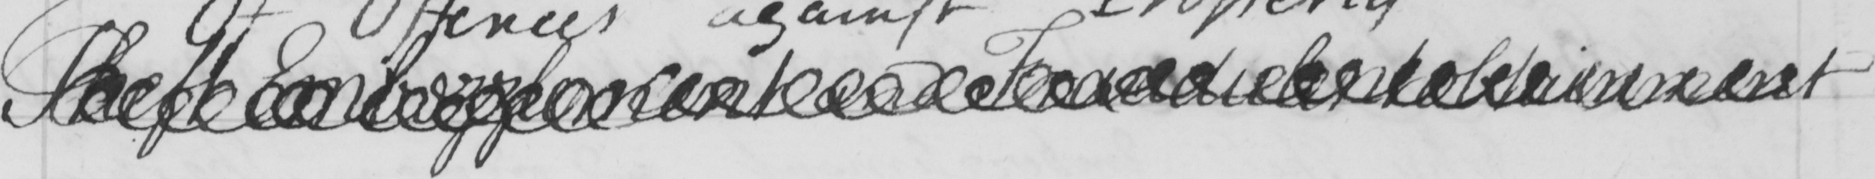What is written in this line of handwriting? Theft Embezzlement and Fraudulent obtainment 